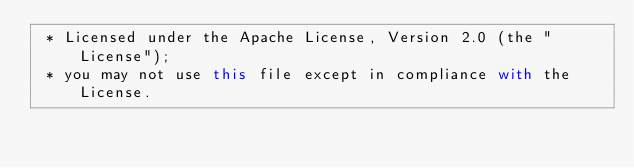<code> <loc_0><loc_0><loc_500><loc_500><_Scala_> * Licensed under the Apache License, Version 2.0 (the "License");
 * you may not use this file except in compliance with the License.</code> 